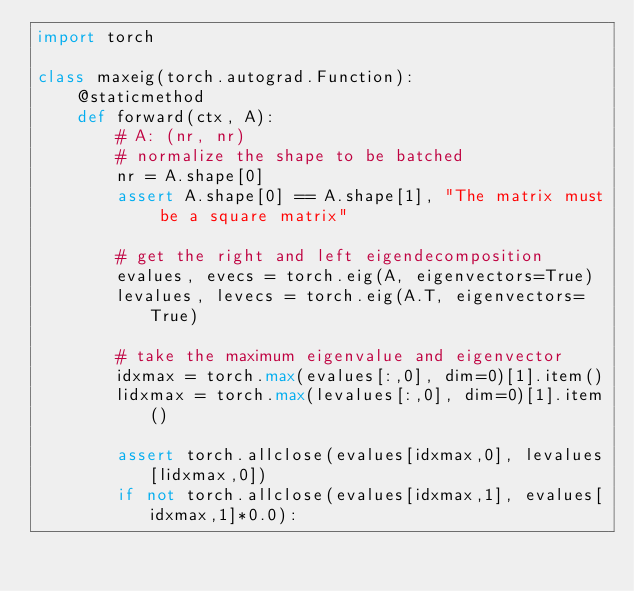Convert code to text. <code><loc_0><loc_0><loc_500><loc_500><_Python_>import torch

class maxeig(torch.autograd.Function):
    @staticmethod
    def forward(ctx, A):
        # A: (nr, nr)
        # normalize the shape to be batched
        nr = A.shape[0]
        assert A.shape[0] == A.shape[1], "The matrix must be a square matrix"

        # get the right and left eigendecomposition
        evalues, evecs = torch.eig(A, eigenvectors=True)
        levalues, levecs = torch.eig(A.T, eigenvectors=True)

        # take the maximum eigenvalue and eigenvector
        idxmax = torch.max(evalues[:,0], dim=0)[1].item()
        lidxmax = torch.max(levalues[:,0], dim=0)[1].item()

        assert torch.allclose(evalues[idxmax,0], levalues[lidxmax,0])
        if not torch.allclose(evalues[idxmax,1], evalues[idxmax,1]*0.0):</code> 